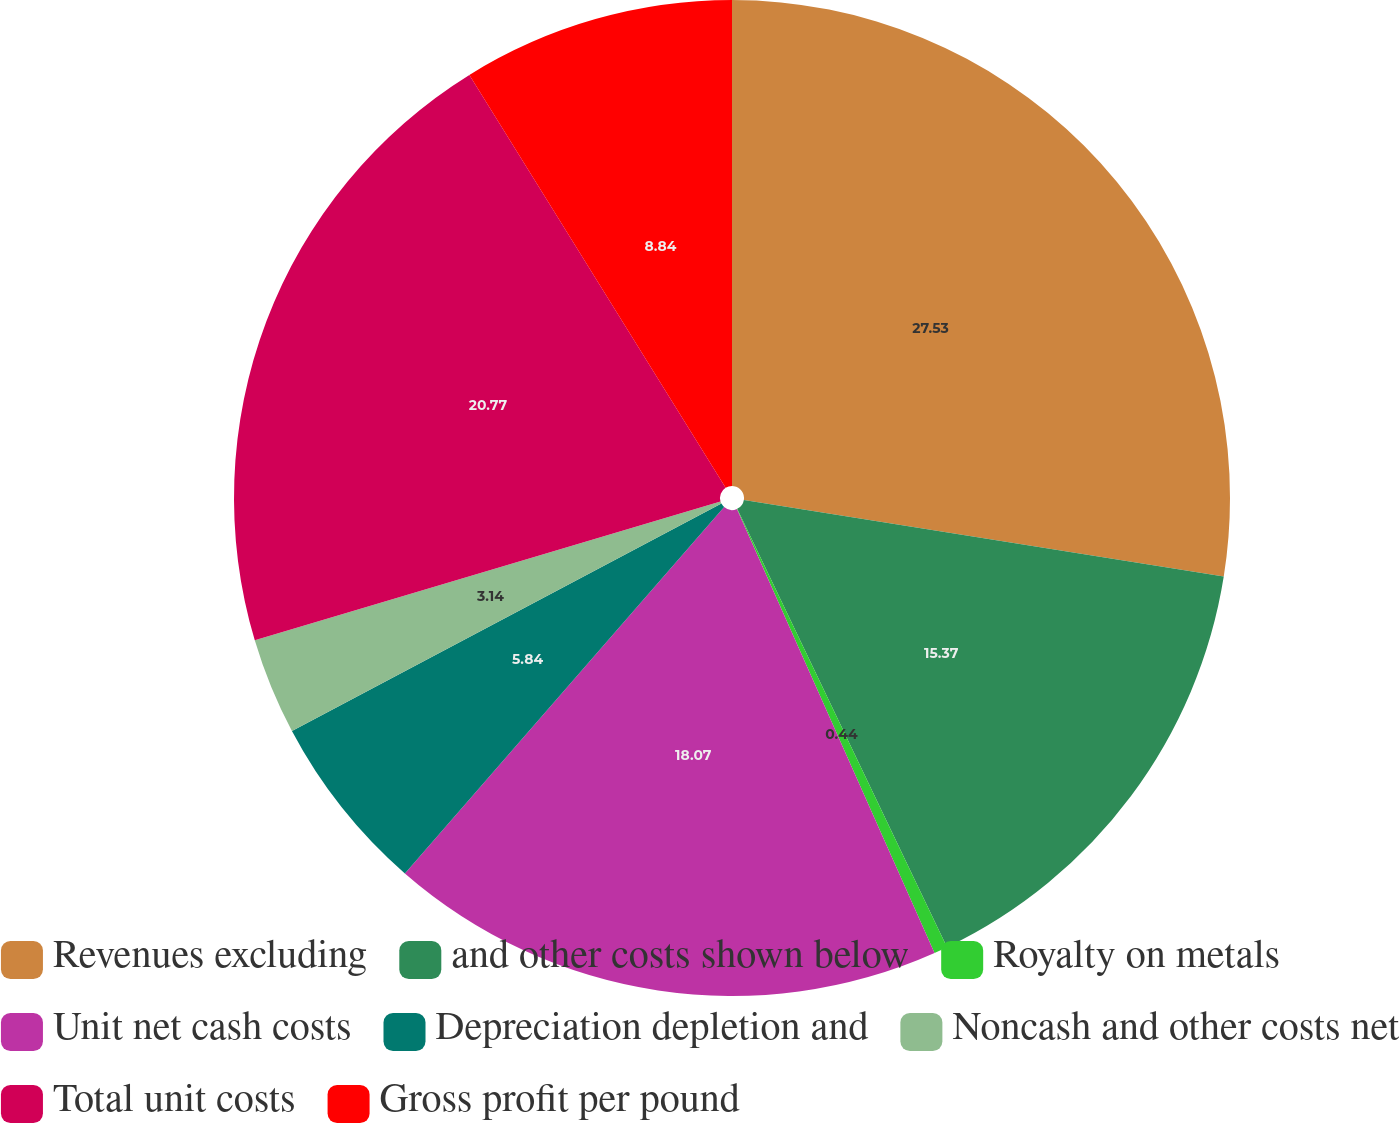Convert chart to OTSL. <chart><loc_0><loc_0><loc_500><loc_500><pie_chart><fcel>Revenues excluding<fcel>and other costs shown below<fcel>Royalty on metals<fcel>Unit net cash costs<fcel>Depreciation depletion and<fcel>Noncash and other costs net<fcel>Total unit costs<fcel>Gross profit per pound<nl><fcel>27.52%<fcel>15.37%<fcel>0.44%<fcel>18.07%<fcel>5.84%<fcel>3.14%<fcel>20.77%<fcel>8.84%<nl></chart> 